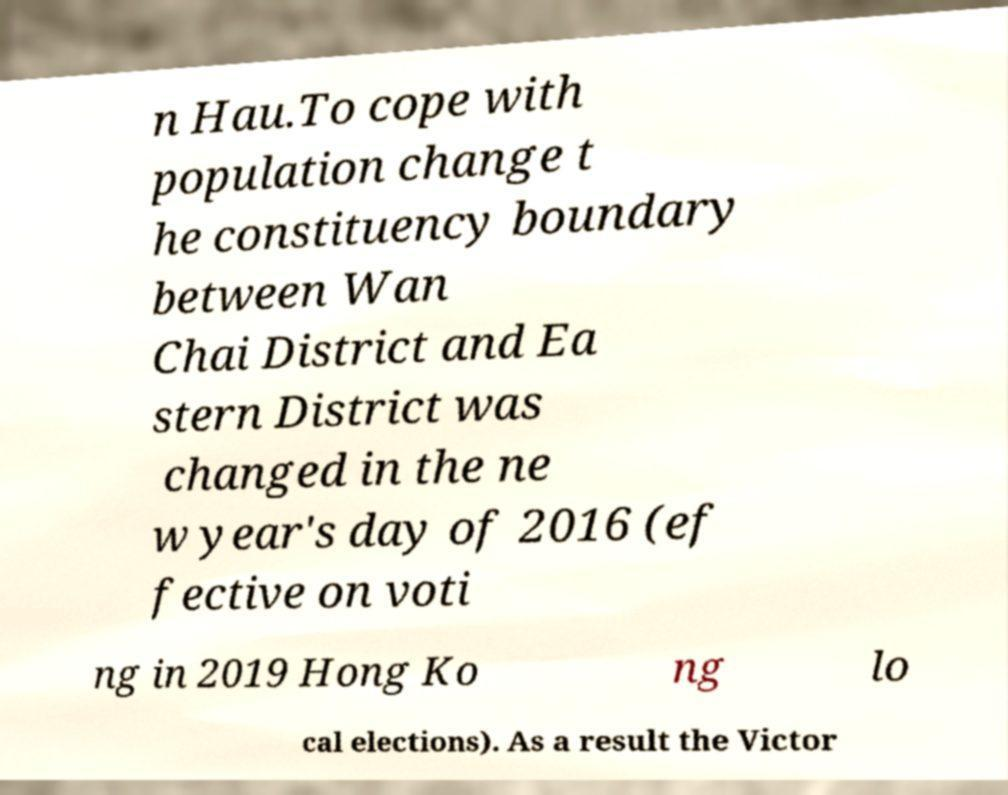Can you accurately transcribe the text from the provided image for me? n Hau.To cope with population change t he constituency boundary between Wan Chai District and Ea stern District was changed in the ne w year's day of 2016 (ef fective on voti ng in 2019 Hong Ko ng lo cal elections). As a result the Victor 